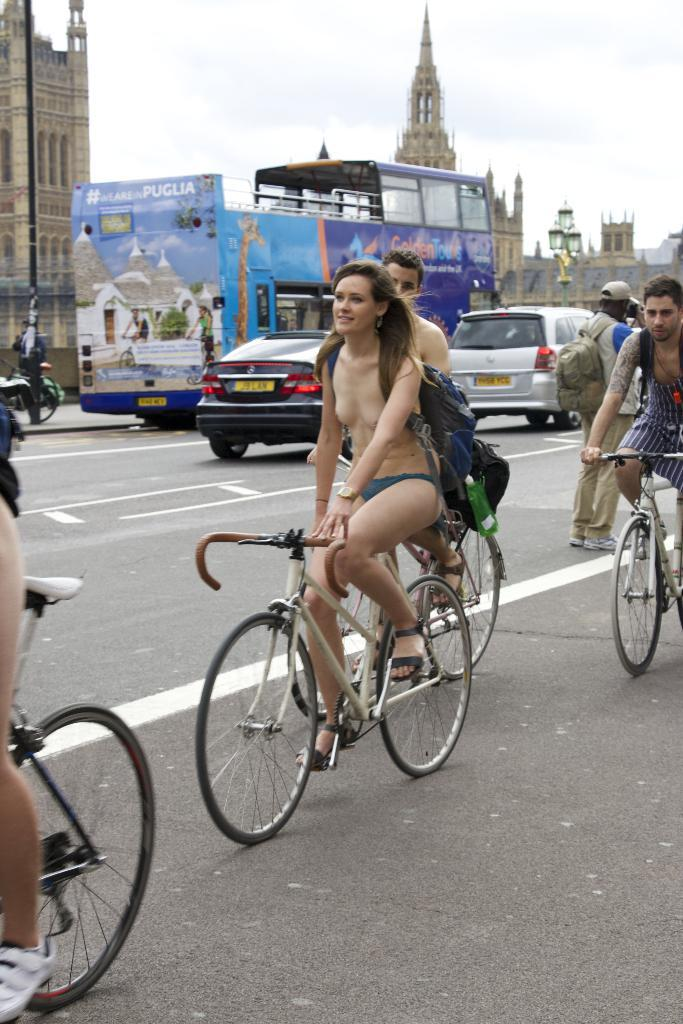What are the persons in the image doing? The persons in the image are riding bicycles on the road. What other vehicles are present on the road? There are cars and buses on the road. What can be seen near the road in the image? There are buildings near the road. What is the condition of the sky in the image? The sky is clear and visible in the image. Can you see any waves in the image? There are no waves present in the image, as it features a scene on a road with vehicles and buildings. What type of peace is depicted in the image? There is no depiction of peace in the image; it is a scene of people and vehicles on a road. 